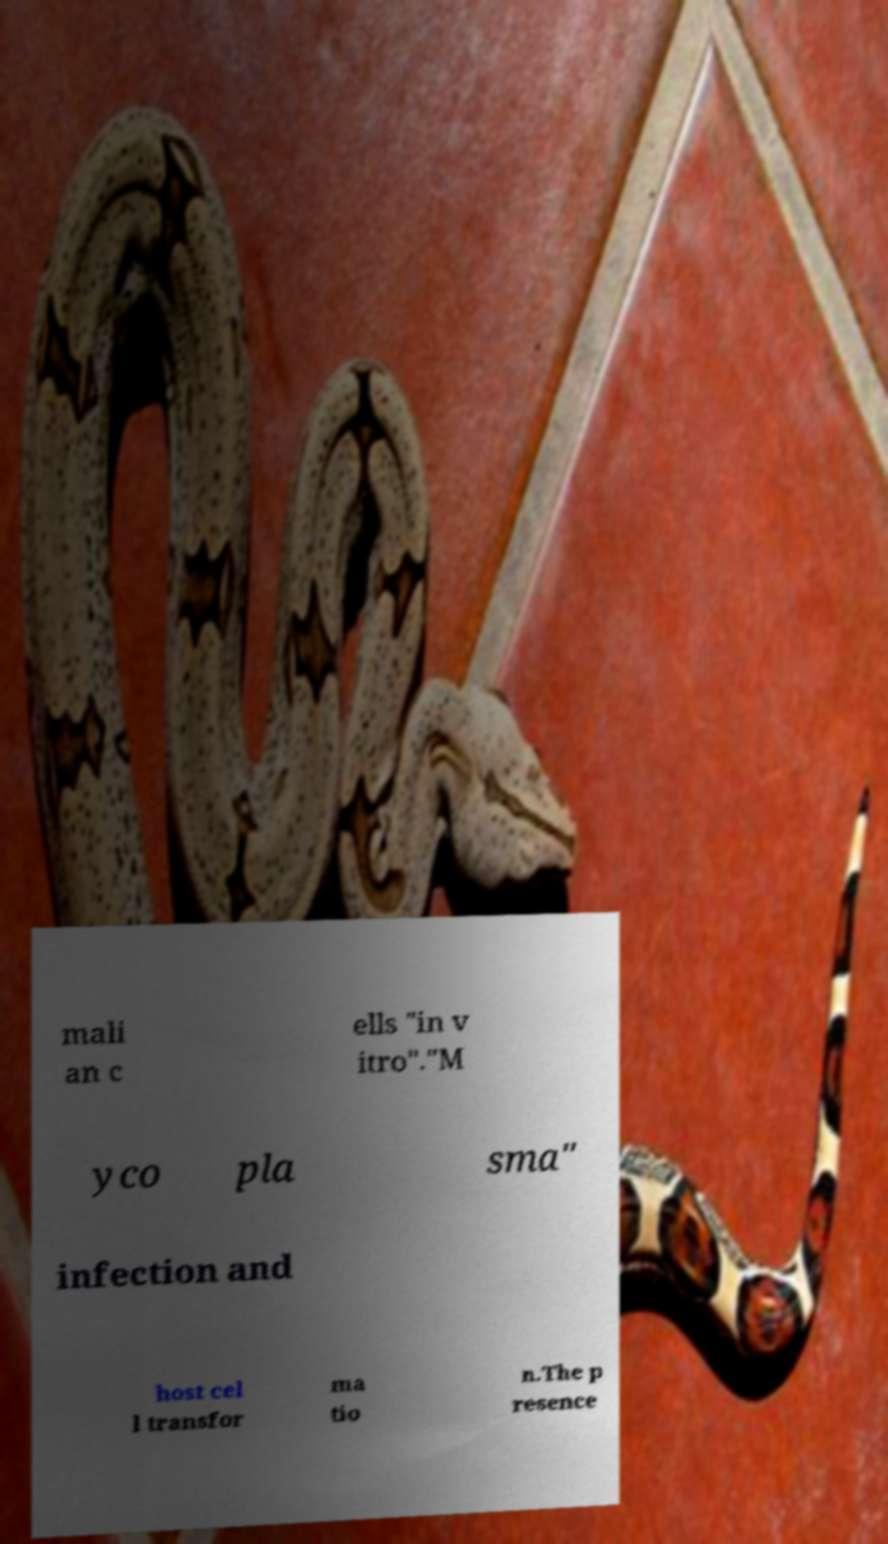For documentation purposes, I need the text within this image transcribed. Could you provide that? mali an c ells "in v itro"."M yco pla sma" infection and host cel l transfor ma tio n.The p resence 